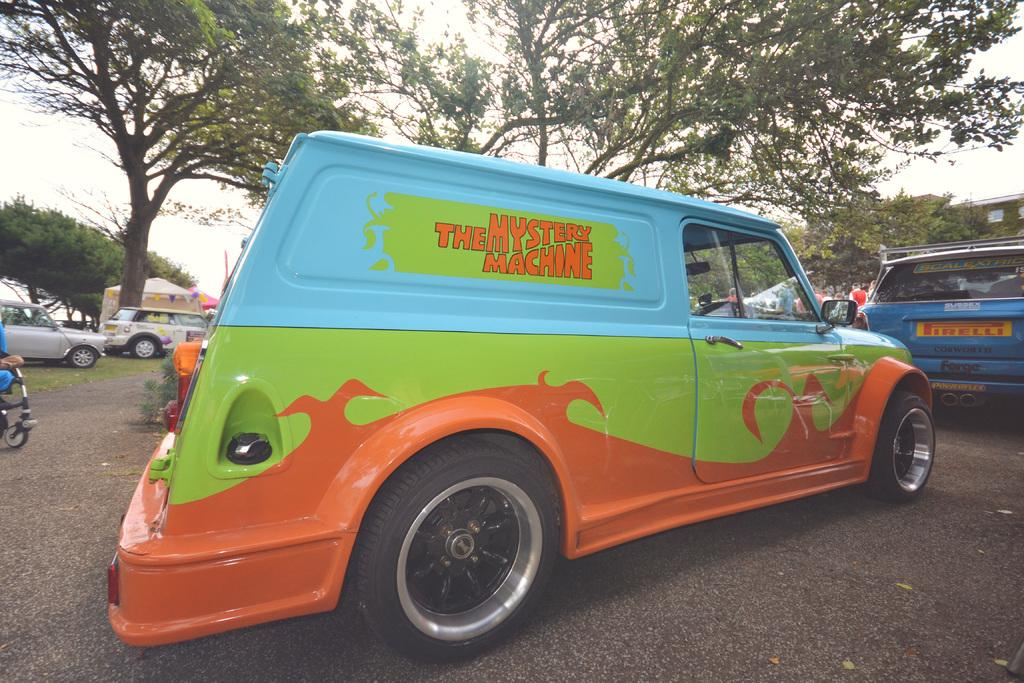What is happening on the road in the image? There are vehicles on the road in the image. What can be seen in the background of the image? There are trees and stalls in the background of the image. What is visible in the sky in the image? The sky is visible in the background of the image. What type of eggnog is being served at the stalls in the image? There is no mention of eggnog in the image; it features vehicles on the road and stalls in the background. How many pages are visible in the image? There are no pages present in the image. 